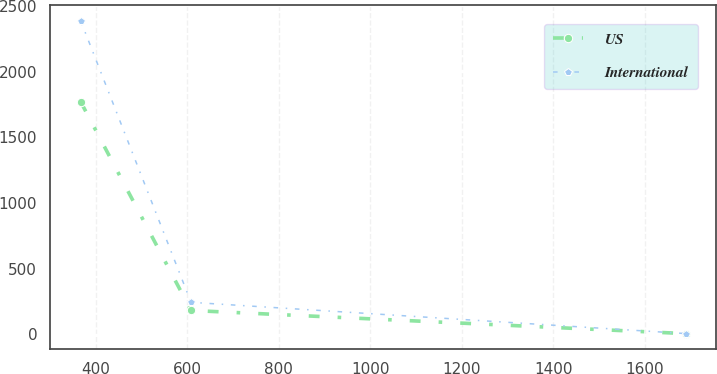Convert chart. <chart><loc_0><loc_0><loc_500><loc_500><line_chart><ecel><fcel>US<fcel>International<nl><fcel>367.43<fcel>1770.72<fcel>2387.51<nl><fcel>608.59<fcel>181.05<fcel>243.03<nl><fcel>1690.18<fcel>4.42<fcel>4.75<nl></chart> 